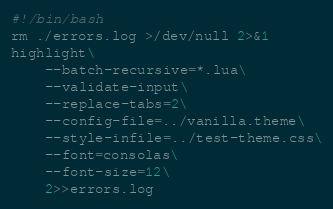<code> <loc_0><loc_0><loc_500><loc_500><_Bash_>#!/bin/bash
rm ./errors.log >/dev/null 2>&1
highlight\
	--batch-recursive=*.lua\
	--validate-input\
	--replace-tabs=2\
	--config-file=../vanilla.theme\
	--style-infile=../test-theme.css\
	--font=consolas\
	--font-size=12\
	2>>errors.log
</code> 